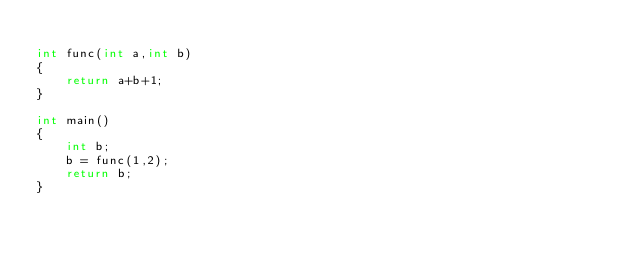<code> <loc_0><loc_0><loc_500><loc_500><_C_>
int func(int a,int b)
{
    return a+b+1;
}

int main()
{
    int b;
    b = func(1,2);
    return b;
}
</code> 